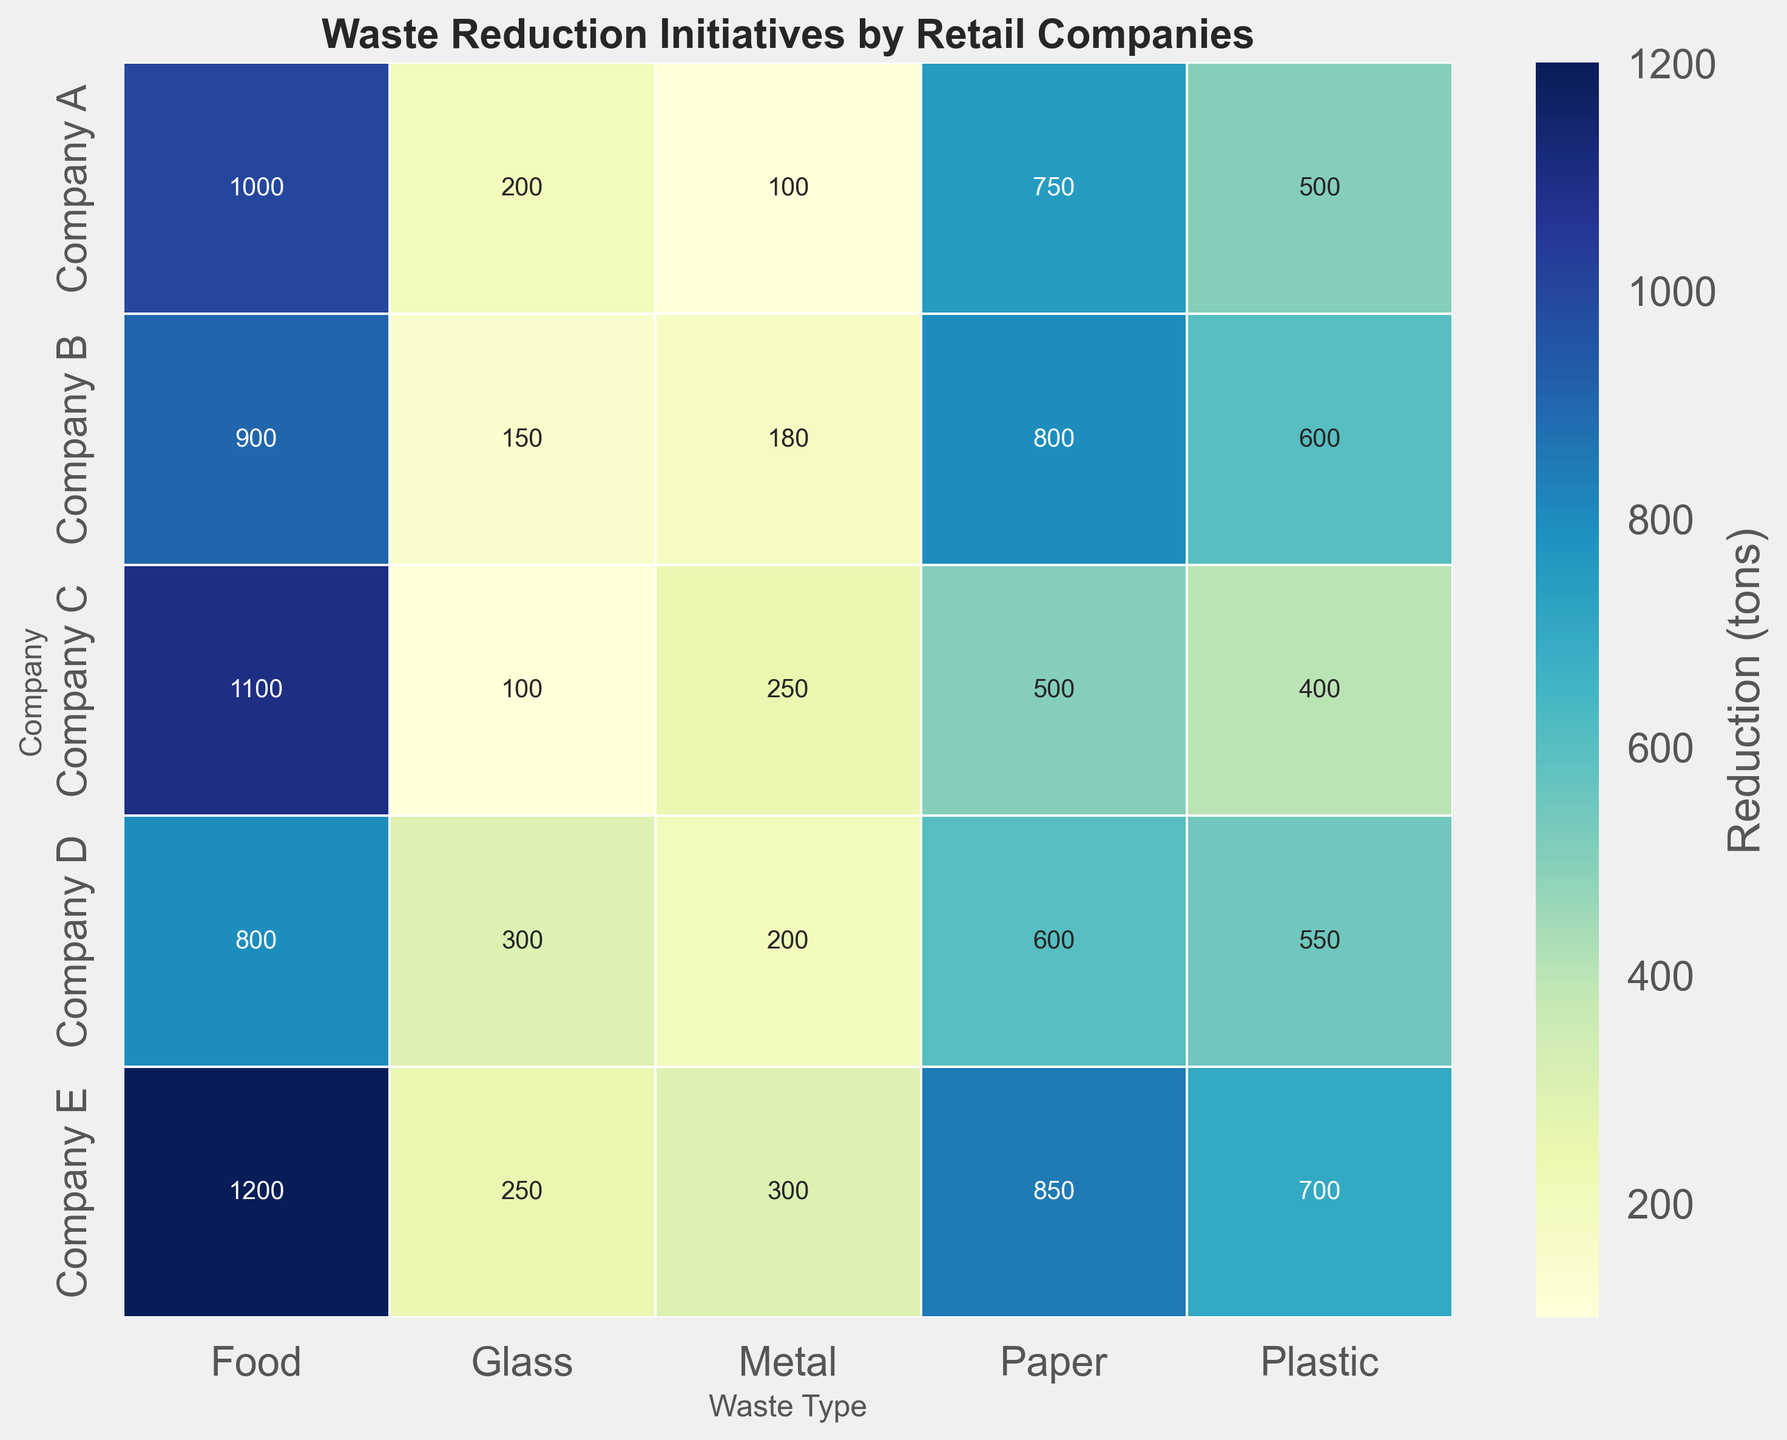What company has the highest total waste reduction? Summing up the reduction values (Plastic, Paper, Glass, Metal, Food) for each company and comparing them: Company A has a total of 2550 tons, Company B has 2630 tons, Company C has 2350 tons, Company D has 2450 tons, and Company E has 3300 tons. Company E has the highest total waste reduction.
Answer: Company E Which waste type has the most substantial reduction across all companies combined? Summing the reduction values for each waste type across all companies: Plastic (500+600+400+550+700 = 2750), Paper (750+800+500+600+850 = 3500), Glass (200+150+100+300+250 = 1000), Metal (100+180+250+200+300 = 1030), Food (1000+900+1100+800+1200 = 5000). Food waste has the most substantial reduction with 5000 tons.
Answer: Food Does any company have the same level of reduction in two different waste types? Checking the values for each company if any two waste types have the same reduction: no company has equal reductions across different waste types.
Answer: No Which company has the smallest reduction in glass waste? Comparing the reduction values for glass waste among companies: Company A (200), Company B (150), Company C (100), Company D (300), and Company E (250). Company C has the smallest reduction in glass waste.
Answer: Company C Which waste type has the least variation in reduction amounts across all companies? Calculating the range (max-min) for each waste type across all companies and comparing them: Plastic (700-400=300), Paper (850-500=350), Glass (300-100=200), Metal (300-100=200), Food (1200-800=400). Glass and Metal both have the same least variation of 200 tons.
Answer: Glass, Metal Between Company B and Company D, which has reduced more paper waste? Comparing the reduction in paper waste between Company B (800 tons) and Company D (600 tons). Company B has reduced more paper waste.
Answer: Company B Which company shows the highest reduction in metal waste? Comparing the reduction values for metal waste among companies: Company A (100), Company B (180), Company C (250), Company D (200), and Company E (300). Company E shows the highest reduction in metal waste.
Answer: Company E How much more food waste has Company C reduced compared to Company D? Subtracting the reduction in food waste of Company D (800 tons) from Company C (1100 tons): 1100-800=300. Company C has reduced 300 tons more food waste than Company D.
Answer: 300 What is the average reduction in plastic waste across all companies? Summing the plastic waste reductions (500+600+400+550+700=2750) and dividing by the number of companies (5): 2750/5=550. The average reduction in plastic waste is 550 tons.
Answer: 550 Which company has the most uniform reduction amounts across all waste types? Checking the variance of reduction values for each company: Company A (variance among 500, 750, 200, 100, 1000), Company B (600, 800, 150, 180, 900), Company C (400, 500, 100, 250, 1100), Company D (550, 600, 300, 200, 800), Company E (700, 850, 250, 300, 1200). Company A shows the most uniform reduction values.
Answer: Company A 